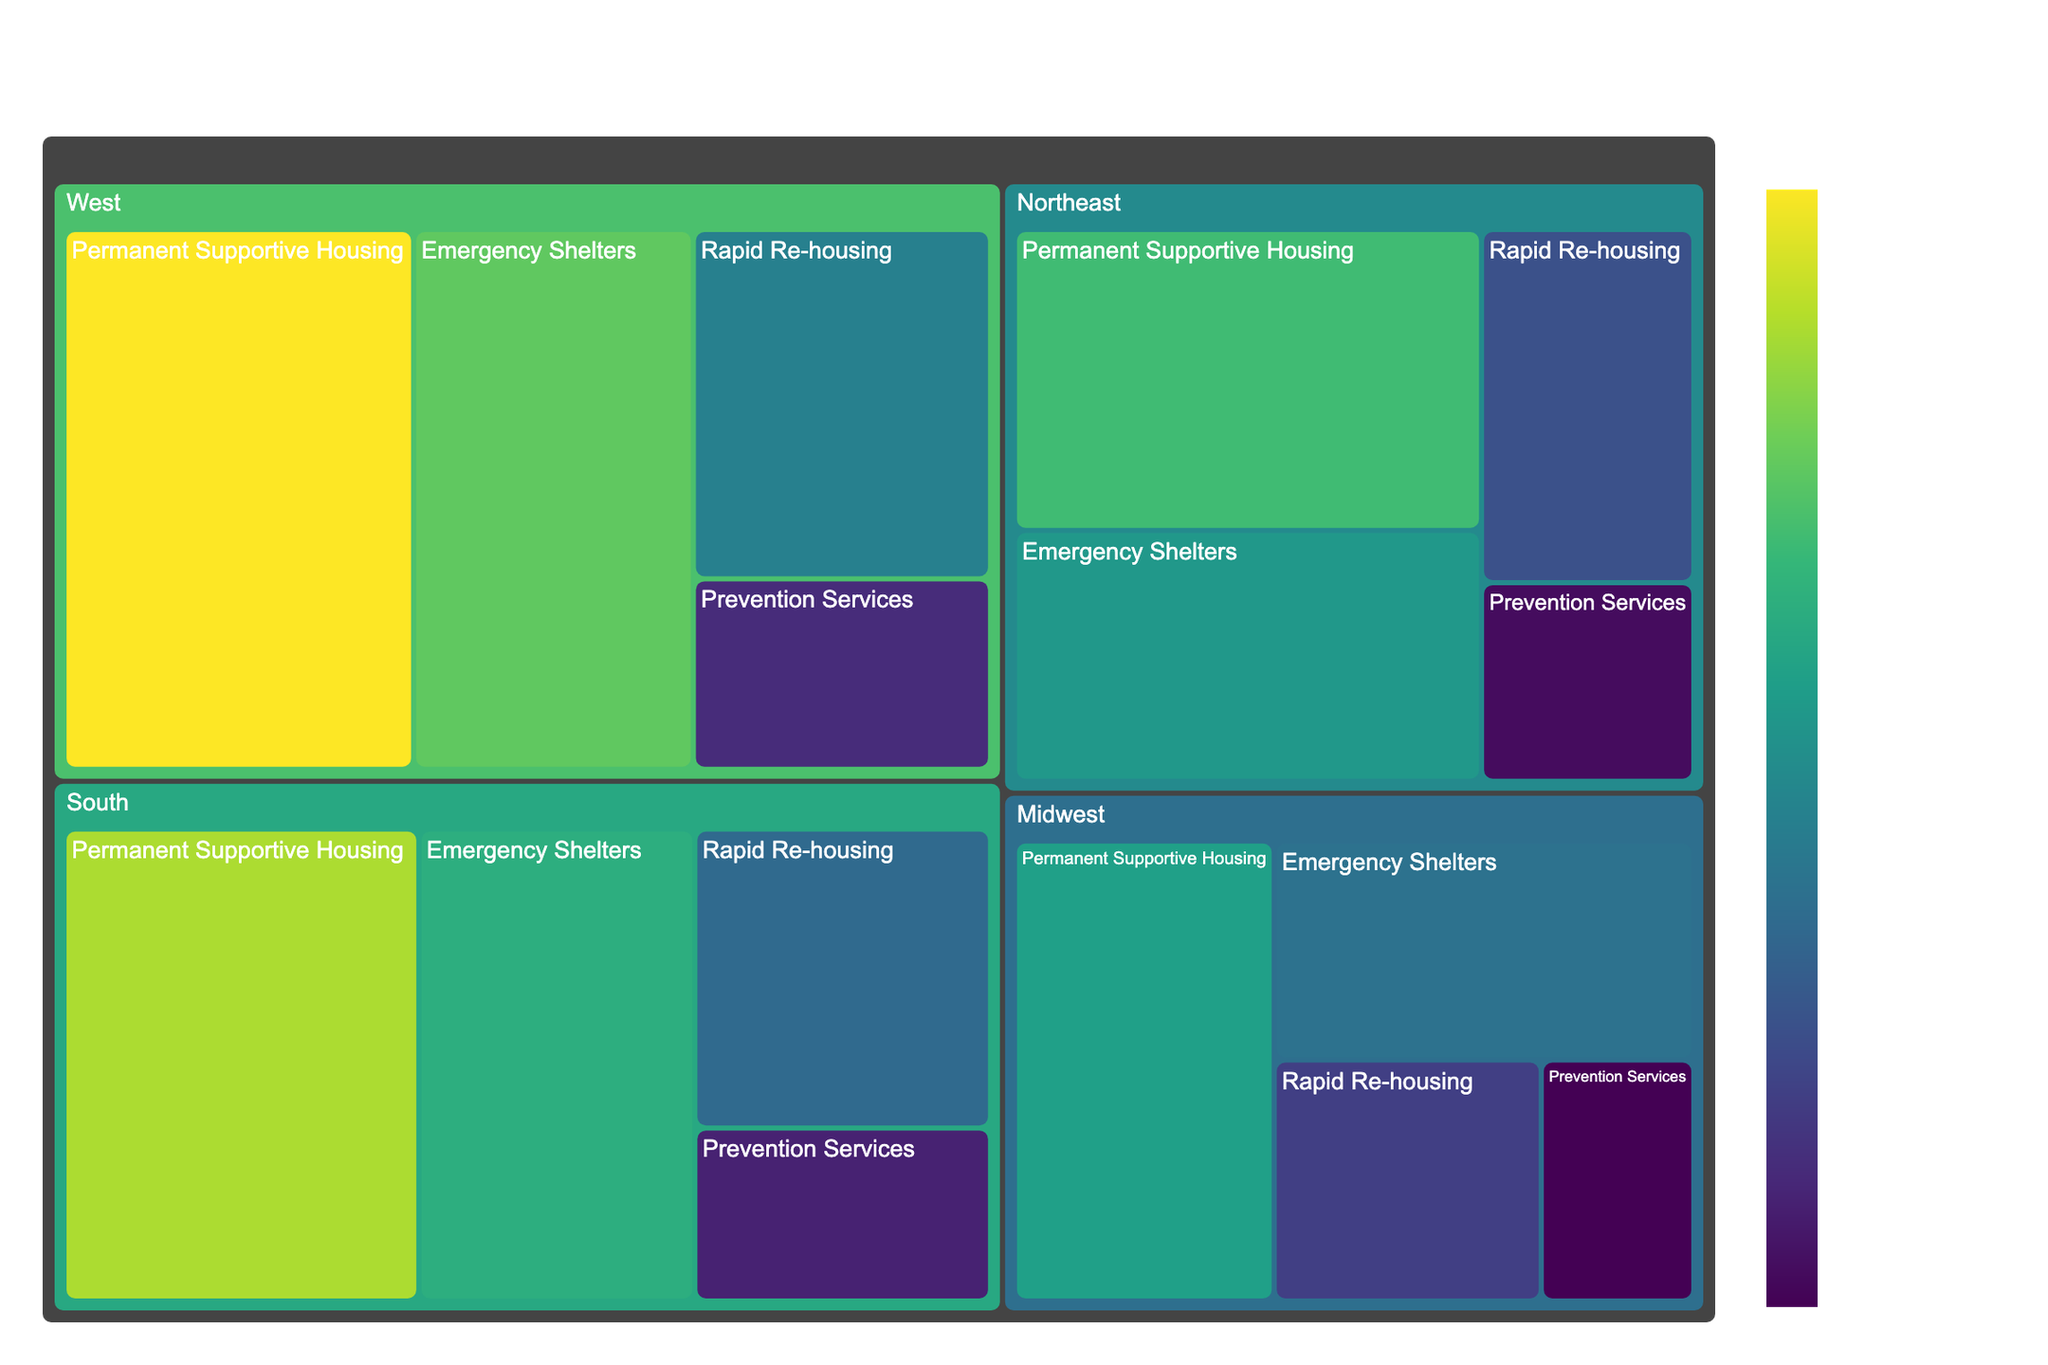How much funding is allocated to Emergency Shelters in the West region? Look at the "West" region section of the treemap and locate the "Emergency Shelters". The funding value is displayed directly inside the section.
Answer: $160 Million What is the total funding for Permanent Supportive Housing programs across all regions? Sum the funding values for Permanent Supportive Housing in all regions: 150 (Northeast) + 130 (Midwest) + 180 (South) + 200 (West). Total is 150 + 130 + 180 + 200 = 660.
Answer: $660 Million Which program type receives the highest funding in the South region? In the "South" region section of the treemap, compare the size of each program type. The largest section corresponds to Permanent Supportive Housing.
Answer: Permanent Supportive Housing What is the average funding across all program types for the Northeast region? Sum the funding values for all program types in the Northeast: 125 (Emergency Shelters) + 80 (Rapid Re-housing) + 150 (Permanent Supportive Housing) + 45 (Prevention Services). The total is 125 + 80 + 150 + 45 = 400. The average is 400/4 = 100.
Answer: $100 Million Compare the funding for Rapid Re-housing programs between the Midwest and the West. Which region has more funding? Look at the funding values for "Rapid Re-housing" in the Midwest (70) and the West (110). The West has more funding.
Answer: West How does the funding for Prevention Services in the South compare to that in the Midwest? Look at the funding values for "Prevention Services" in the South (55) and the Midwest (40). The South has more funding.
Answer: South Which region has the lowest total funding for all homeless services combined? Sum the total funding for each region and compare:
Northeast: 125 + 80 + 150 + 45 = 400
Midwest: 100 + 70 + 130 + 40 = 340
South: 140 + 95 + 180 + 55 = 470
West: 160 + 110 + 200 + 60 = 530
The Midwest has the lowest total funding.
Answer: Midwest If we rank the regions by the amount of funding for Emergency Shelters, what position does the Northeast hold? Compare the Emergency Shelters funding values: Northeast (125), Midwest (100), South (140), West (160). Ranking from highest to lowest: West, South, Northeast, Midwest. The Northeast is third.
Answer: 3rd What is the difference in funding between Rapid Re-housing in the Northeast and the South? Subtract the funding for Rapid Re-housing in the Northeast (80) from that in the South (95). The difference is 95 - 80 = 15.
Answer: $15 Million What percentage of the total Northeast region funding is allocated to Emergency Shelters? Calculate the total funding for the Northeast (125 + 80 + 150 + 45 = 400). The percentage for Emergency Shelters is (125/400) * 100%. This gives (125/400) * 100 = 31.25%.
Answer: 31.25% 